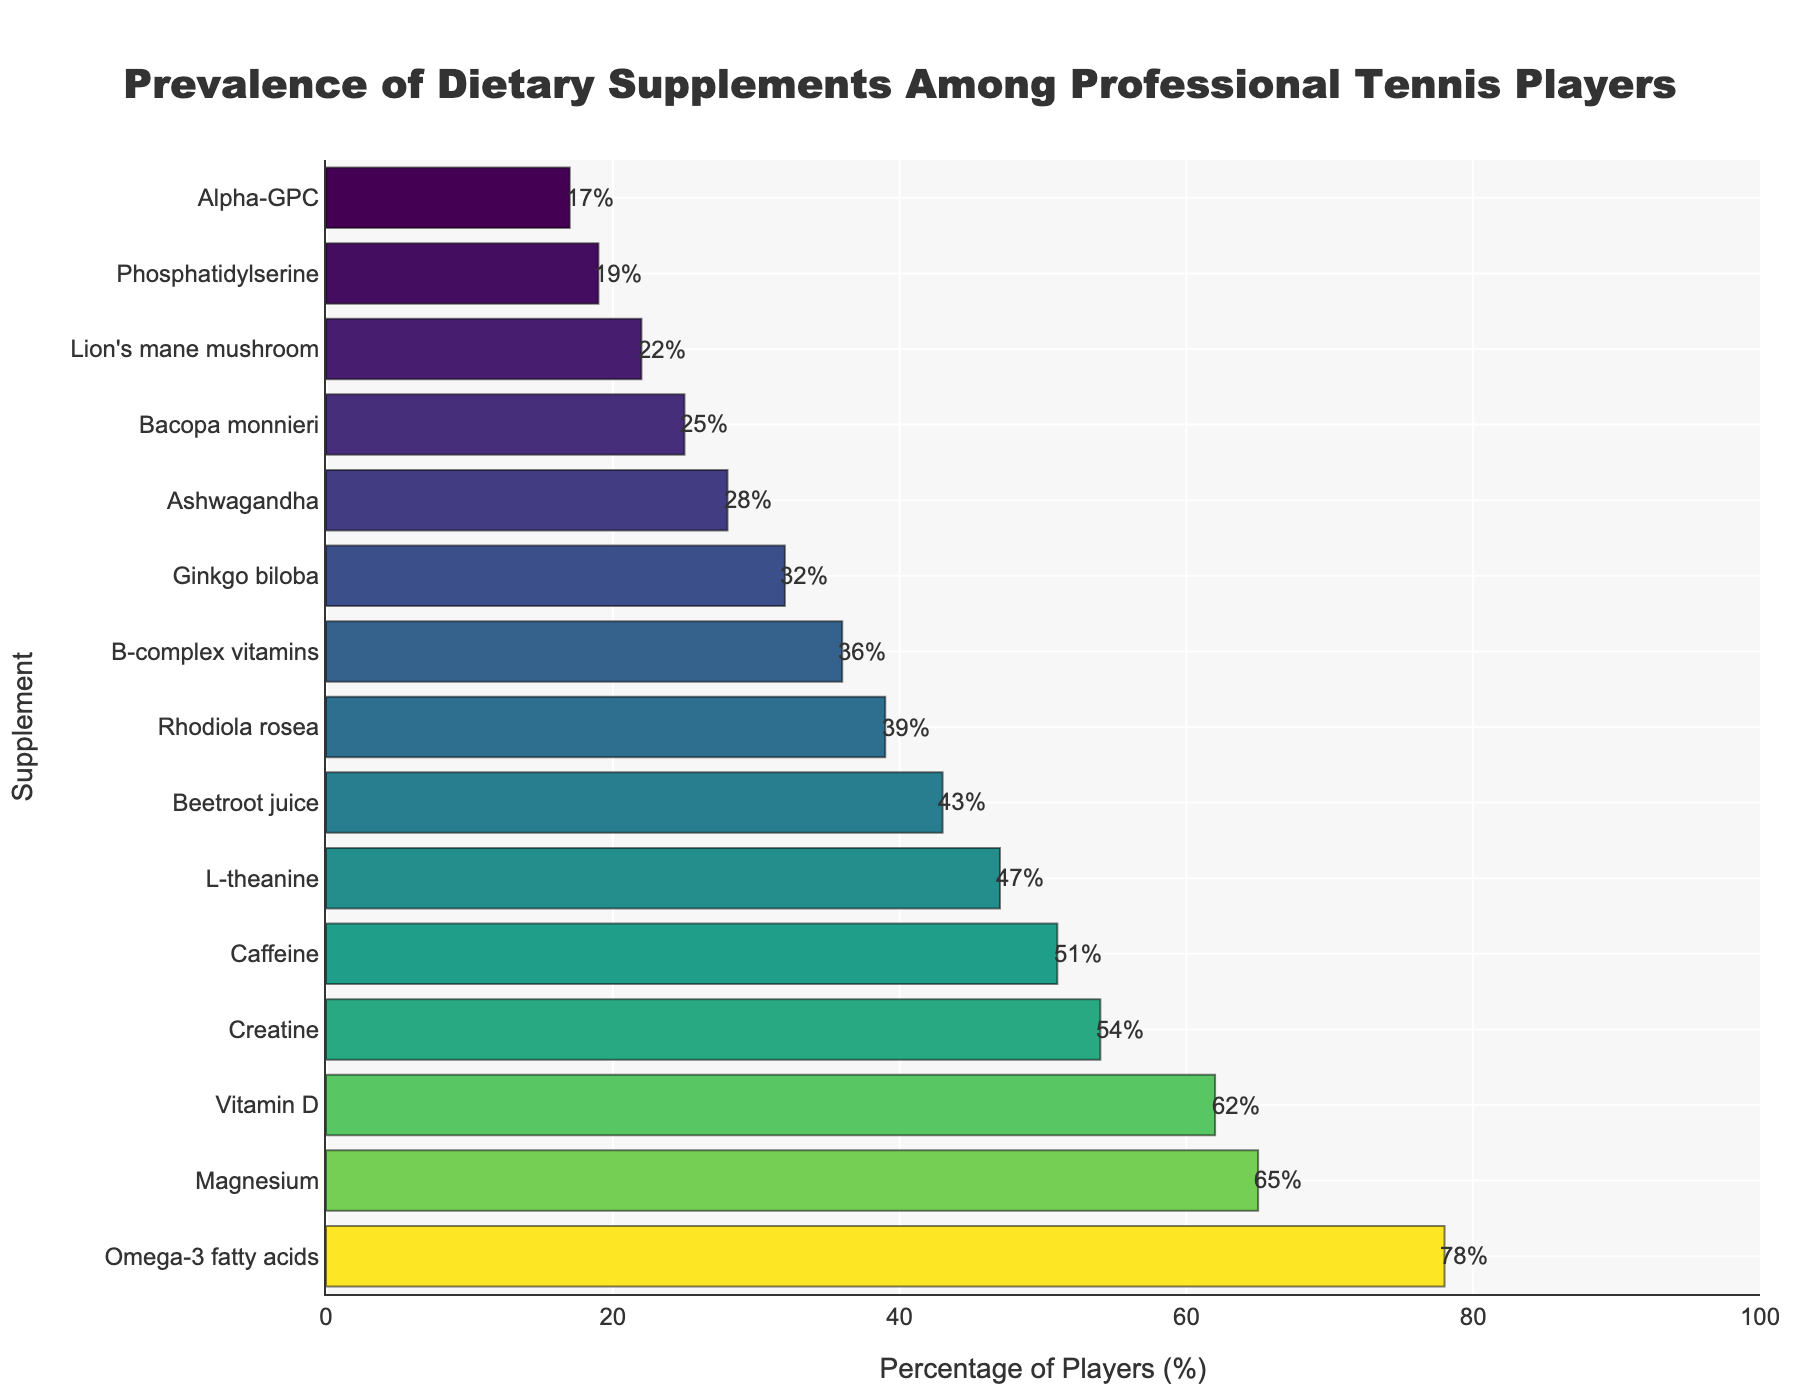Which supplement is the most prevalent among professional tennis players? The bar chart shows the prevalence of different dietary supplements among professional tennis players. The supplement with the highest percentage bar is Omega-3 fatty acids, which is at 78%.
Answer: Omega-3 fatty acids What is the difference in prevalence between Magnesium and Ashwagandha? The bar chart indicates that Magnesium has a prevalence of 65% and Ashwagandha has a prevalence of 28%. Subtracting 28% from 65% gives the difference in prevalence.
Answer: 37% How many supplements have a prevalence of at least 50%? From the bar chart, it is clear that Omega-3 fatty acids (78%), Magnesium (65%), Vitamin D (62%), Creatine (54%), and Caffeine (51%) all have a prevalence of at least 50%. Counting these bars results in 5 supplements.
Answer: 5 Which has a higher prevalence, L-theanine or Beetroot juice? By comparing the heights of their respective bars, L-theanine has a prevalence of 47% while Beetroot juice has a prevalence of 43%. Thus, L-theanine has a higher prevalence than Beetroot juice.
Answer: L-theanine If the average prevalence of the top 3 supplements is calculated, what will it be? The top three supplements based on prevalence are Omega-3 fatty acids (78%), Magnesium (65%), and Vitamin D (62%). Adding these percentages and then dividing by 3 gives the average: (78% + 65% + 62%) / 3 = 68.33%.
Answer: 68.33% Is the prevalence of Alpha-GPC greater than or less than half the prevalence of Omega-3 fatty acids? The prevalence of Omega-3 fatty acids is 78%. Half of this value is 39%. The prevalence of Alpha-GPC is 17%, which is less than 39%.
Answer: Less What is the average prevalence of the bottom 5 supplements? The bottom 5 supplements based on the data are Alpha-GPC (17%), Phosphatidylserine (19%), Lion's mane mushroom (22%), Bacopa monnieri (25%), and Ashwagandha (28%). The average prevalence is calculated as (17% + 19% + 22% + 25% + 28%) / 5 = 22.2%.
Answer: 22.2% Which supplement has the closest prevalence to 50%? The bar chart shows that Caffeine has a prevalence of 51%, which is the closest to 50%.
Answer: Caffeine What is the total prevalence of the four least prevalent supplements? The four least prevalent supplements are Alpha-GPC (17%), Phosphatidylserine (19%), Lion's mane mushroom (22%), and Bacopa monnieri (25%). Summing these percentages gives 17% + 19% + 22% + 25% = 83%.
Answer: 83% Is the prevalence of Ginkgo biloba higher or lower than the prevalence of Vitamin D? The bar chart indicates that Ginkgo biloba has a prevalence of 32%, while Vitamin D has a prevalence of 62%. Therefore, the prevalence of Ginkgo biloba is lower.
Answer: Lower 